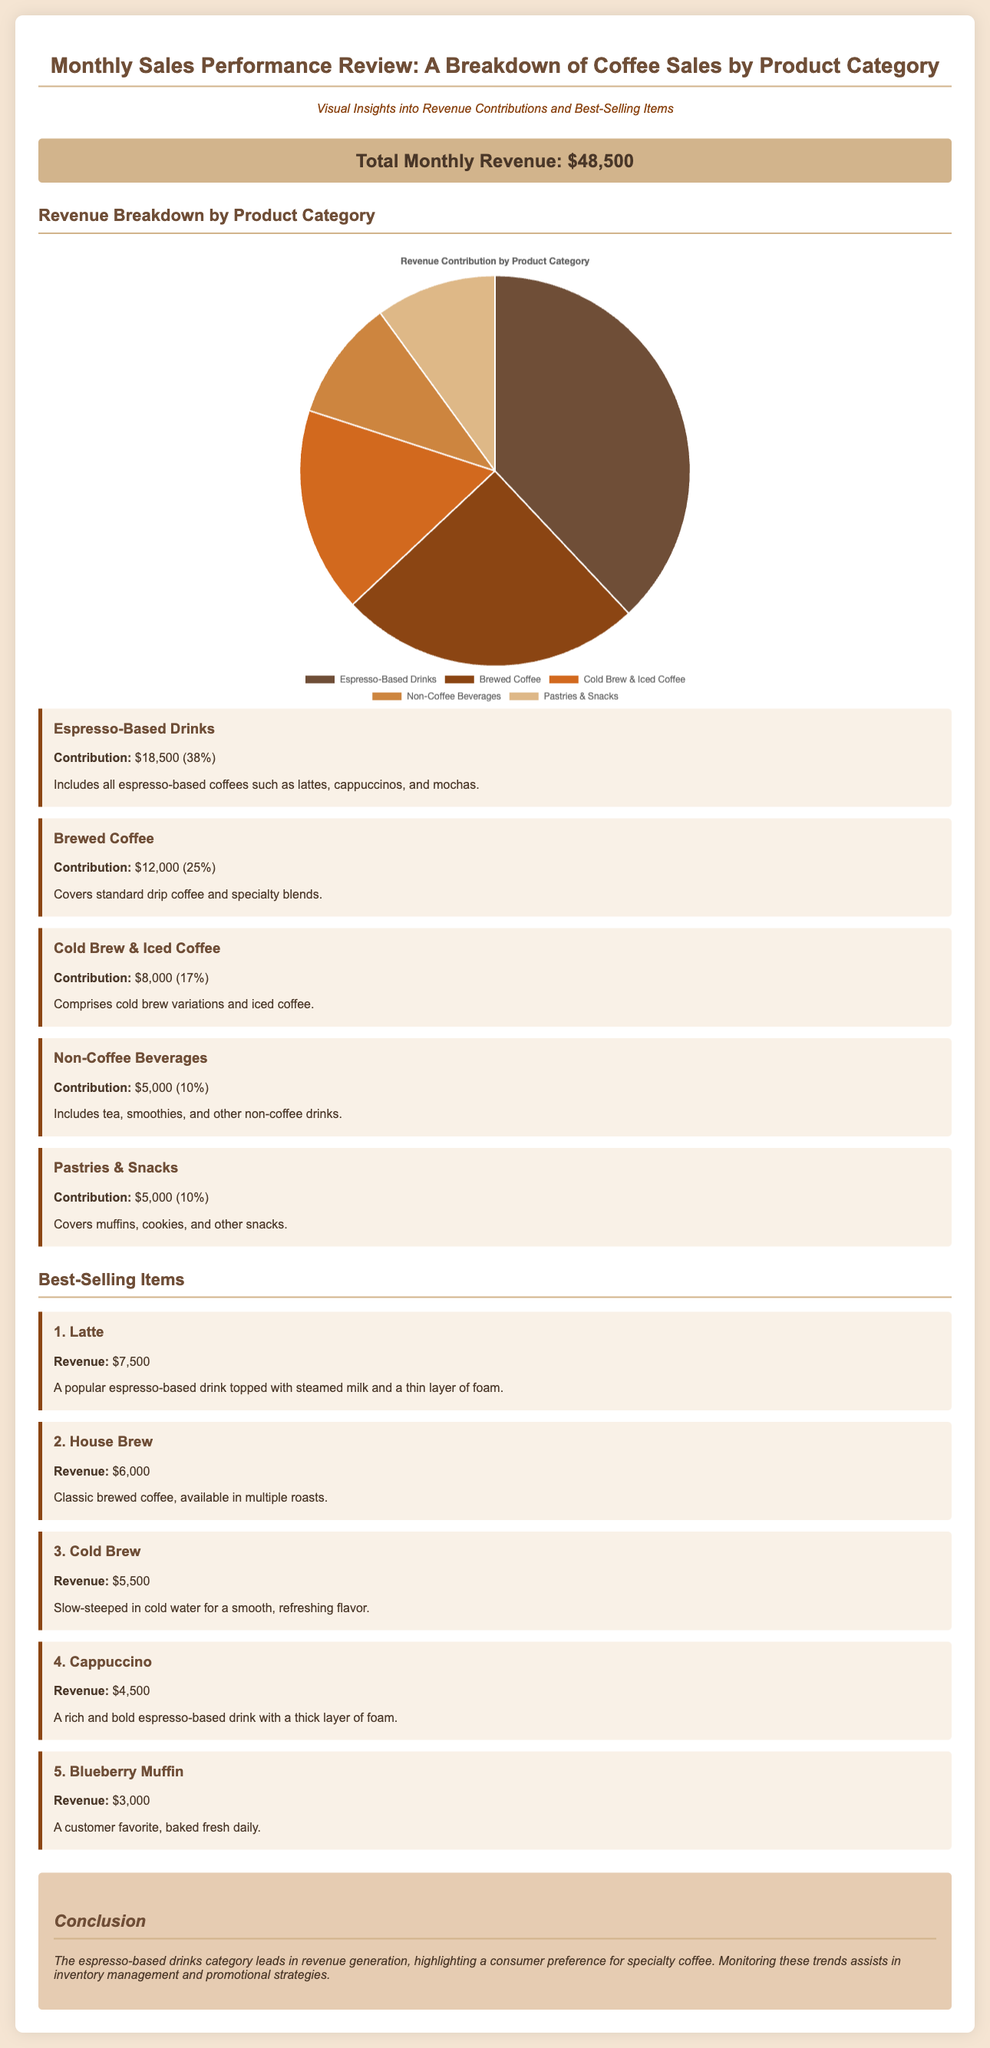what is the total revenue? The total revenue is explicitly stated in the document as $48,500.
Answer: $48,500 what product category contributes the most to revenue? The product category with the highest contribution is Espresso-Based Drinks, listed in the revenue breakdown.
Answer: Espresso-Based Drinks how much revenue does brewed coffee generate? Brewed Coffee's contribution is noted in the document as $12,000, indicating its revenue generation.
Answer: $12,000 which item is the best-selling? The best-selling item is indicated as the Latte, which is mentioned first in the best-selling items section.
Answer: Latte what percentage of total revenue comes from cold brew and iced coffee? Cold Brew & Iced Coffee contributes 17%, as detailed in the revenue breakdown section.
Answer: 17% how much revenue do pastries and snacks generate? The revenue contribution for Pastries & Snacks is stated as $5,000 in the document.
Answer: $5,000 what is the total percentage contribution of non-coffee beverages? Non-Coffee Beverages contribute 10% of the total revenue, as represented in the breakdown.
Answer: 10% which best-selling item generates $4,500 in revenue? The document specifies that the Cappuccino generates $4,500 in revenue among the best-selling items.
Answer: Cappuccino what type of chart is used to represent revenue contribution by product category? The chart type used is a pie chart, as indicated in the document for visual representation.
Answer: pie chart 